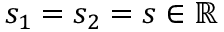Convert formula to latex. <formula><loc_0><loc_0><loc_500><loc_500>s _ { 1 } = s _ { 2 } = s \in \mathbb { R }</formula> 